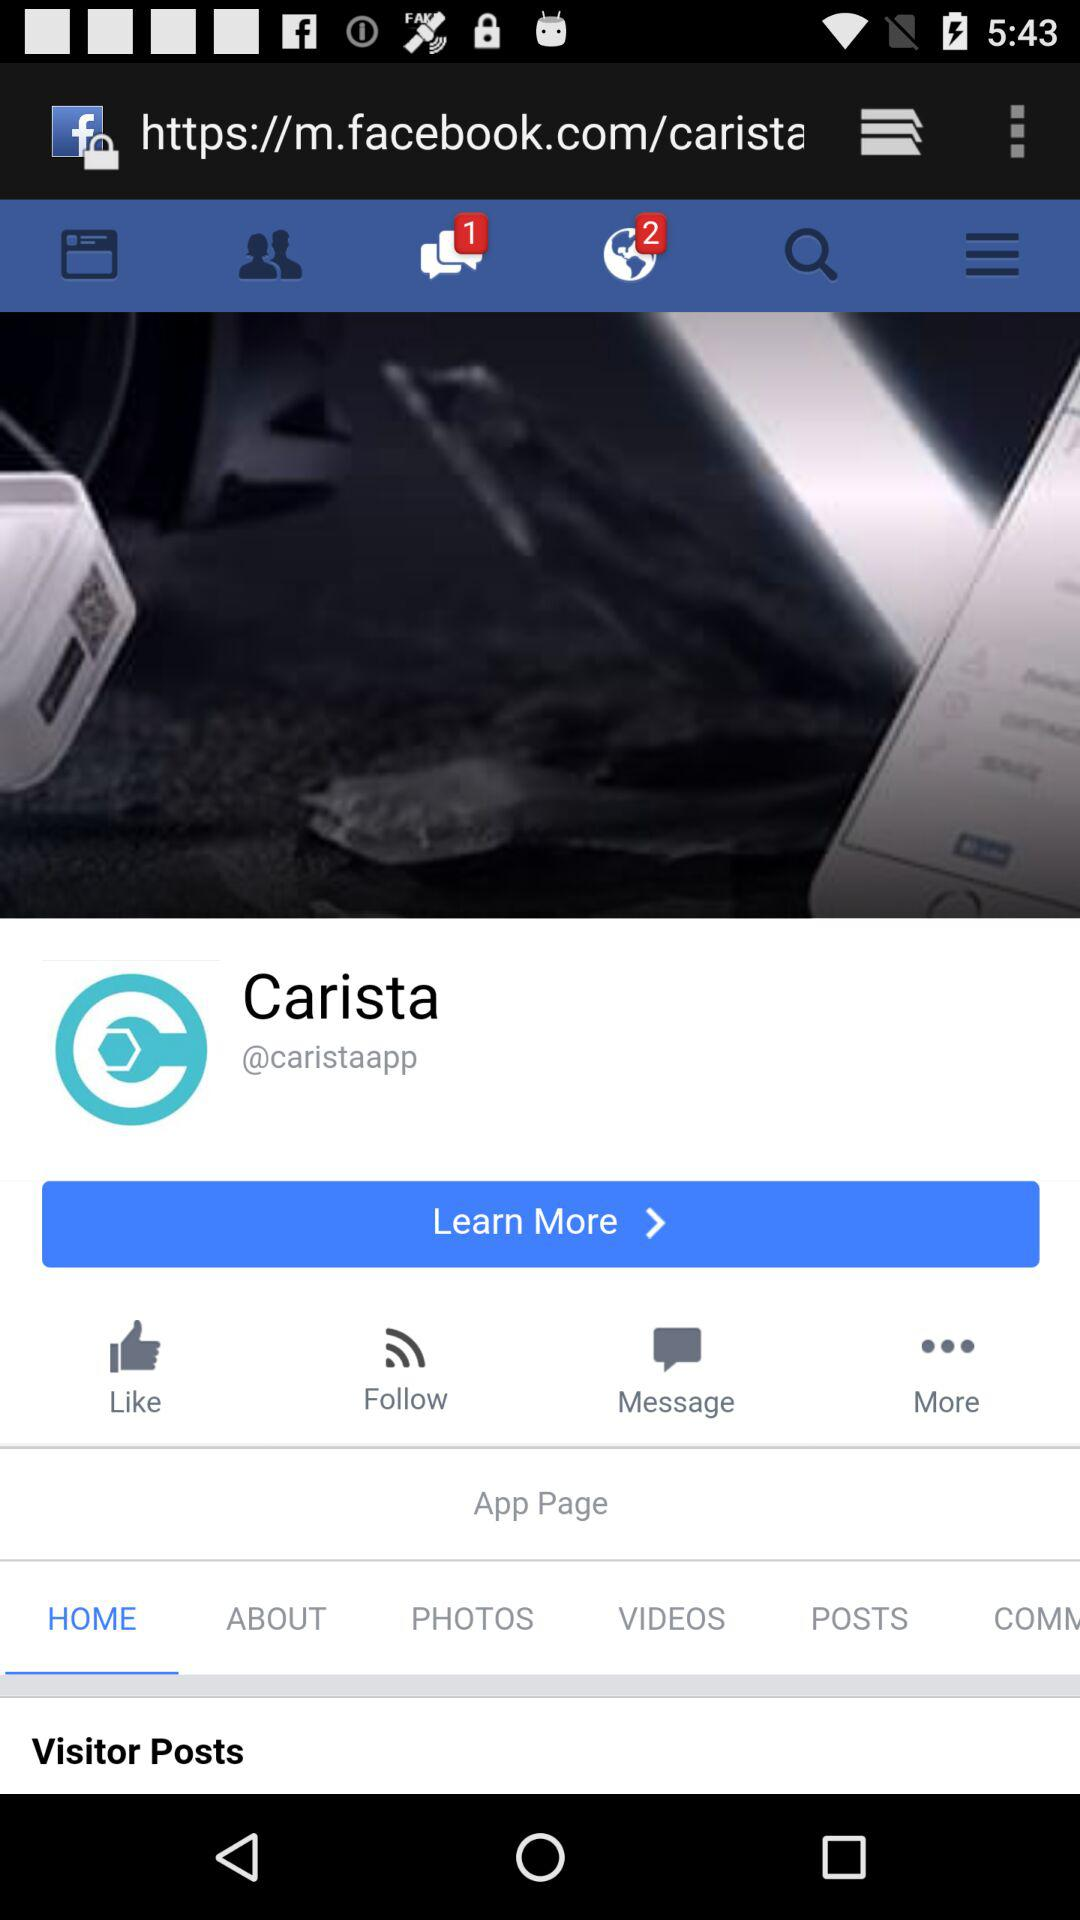Are there any unread messages? There is 1 unread message. 